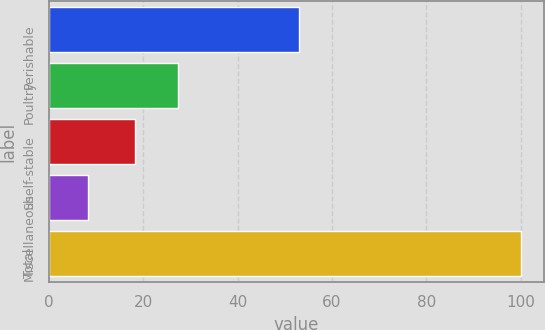Convert chart. <chart><loc_0><loc_0><loc_500><loc_500><bar_chart><fcel>Perishable<fcel>Poultry<fcel>Shelf-stable<fcel>Miscellaneous<fcel>Total<nl><fcel>53.1<fcel>27.38<fcel>18.2<fcel>8.2<fcel>100<nl></chart> 